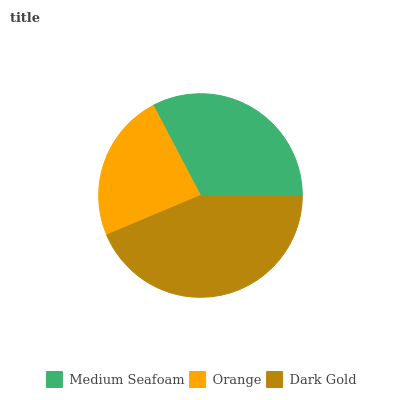Is Orange the minimum?
Answer yes or no. Yes. Is Dark Gold the maximum?
Answer yes or no. Yes. Is Dark Gold the minimum?
Answer yes or no. No. Is Orange the maximum?
Answer yes or no. No. Is Dark Gold greater than Orange?
Answer yes or no. Yes. Is Orange less than Dark Gold?
Answer yes or no. Yes. Is Orange greater than Dark Gold?
Answer yes or no. No. Is Dark Gold less than Orange?
Answer yes or no. No. Is Medium Seafoam the high median?
Answer yes or no. Yes. Is Medium Seafoam the low median?
Answer yes or no. Yes. Is Dark Gold the high median?
Answer yes or no. No. Is Orange the low median?
Answer yes or no. No. 